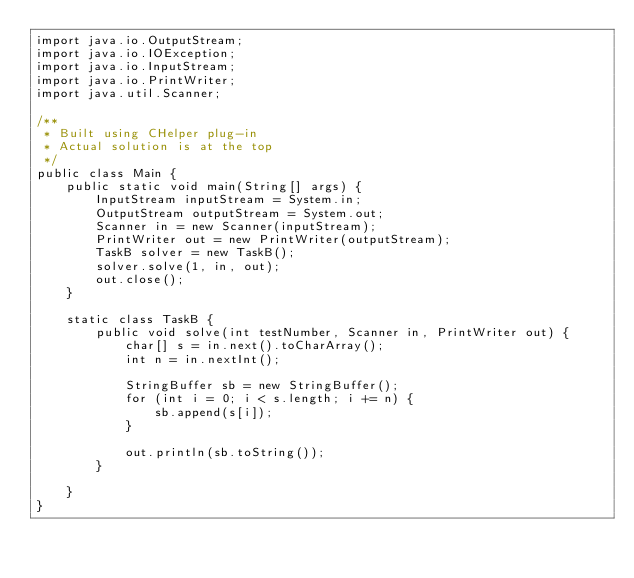Convert code to text. <code><loc_0><loc_0><loc_500><loc_500><_Java_>import java.io.OutputStream;
import java.io.IOException;
import java.io.InputStream;
import java.io.PrintWriter;
import java.util.Scanner;

/**
 * Built using CHelper plug-in
 * Actual solution is at the top
 */
public class Main {
    public static void main(String[] args) {
        InputStream inputStream = System.in;
        OutputStream outputStream = System.out;
        Scanner in = new Scanner(inputStream);
        PrintWriter out = new PrintWriter(outputStream);
        TaskB solver = new TaskB();
        solver.solve(1, in, out);
        out.close();
    }

    static class TaskB {
        public void solve(int testNumber, Scanner in, PrintWriter out) {
            char[] s = in.next().toCharArray();
            int n = in.nextInt();

            StringBuffer sb = new StringBuffer();
            for (int i = 0; i < s.length; i += n) {
                sb.append(s[i]);
            }

            out.println(sb.toString());
        }

    }
}

</code> 